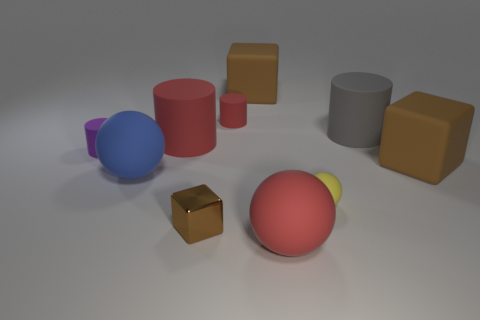What is the size of the purple cylinder that is made of the same material as the gray thing?
Make the answer very short. Small. What is the shape of the large gray thing?
Make the answer very short. Cylinder. Do the tiny purple cylinder and the brown object left of the tiny red matte object have the same material?
Give a very brief answer. No. What number of things are big red rubber spheres or red cubes?
Your response must be concise. 1. Are any big cyan objects visible?
Your answer should be compact. No. What is the shape of the tiny brown thing in front of the large red matte object that is behind the small brown cube?
Ensure brevity in your answer.  Cube. What number of things are big objects that are behind the blue sphere or red objects that are behind the blue matte sphere?
Offer a very short reply. 5. What material is the blue object that is the same size as the gray cylinder?
Offer a very short reply. Rubber. What color is the small ball?
Ensure brevity in your answer.  Yellow. What is the cylinder that is both on the left side of the tiny red cylinder and on the right side of the tiny purple rubber thing made of?
Provide a short and direct response. Rubber. 